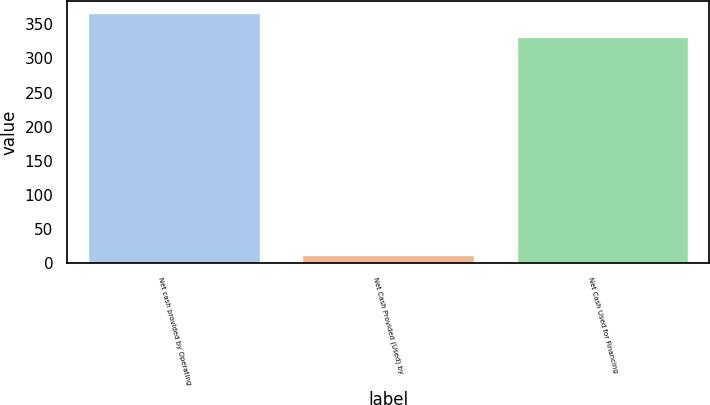<chart> <loc_0><loc_0><loc_500><loc_500><bar_chart><fcel>Net cash provided by Operating<fcel>Net Cash Provided (Used) by<fcel>Net Cash Used for Financing<nl><fcel>366.14<fcel>12<fcel>331<nl></chart> 